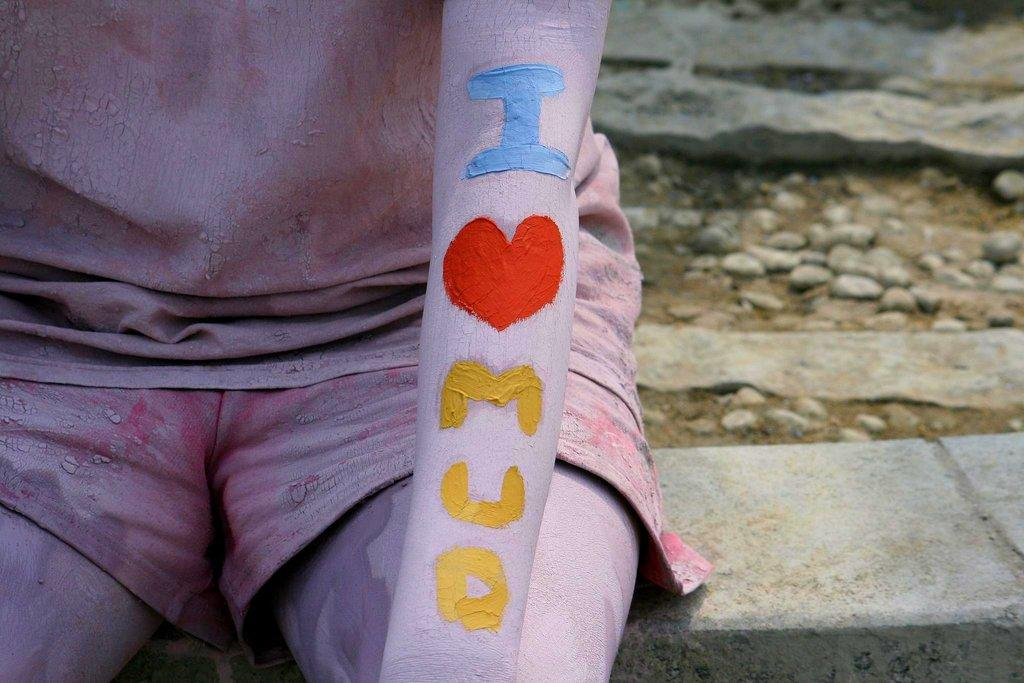What is the person in the image doing? The person is sitting on the left side of the image. What is on the person's hand? The person has a painting on their hand. What can be seen on the right side of the image? There are stones and sand on the right side of the image. What type of jewel is the person crushing in the image? There is no jewel present in the image, and the person is not crushing anything. 